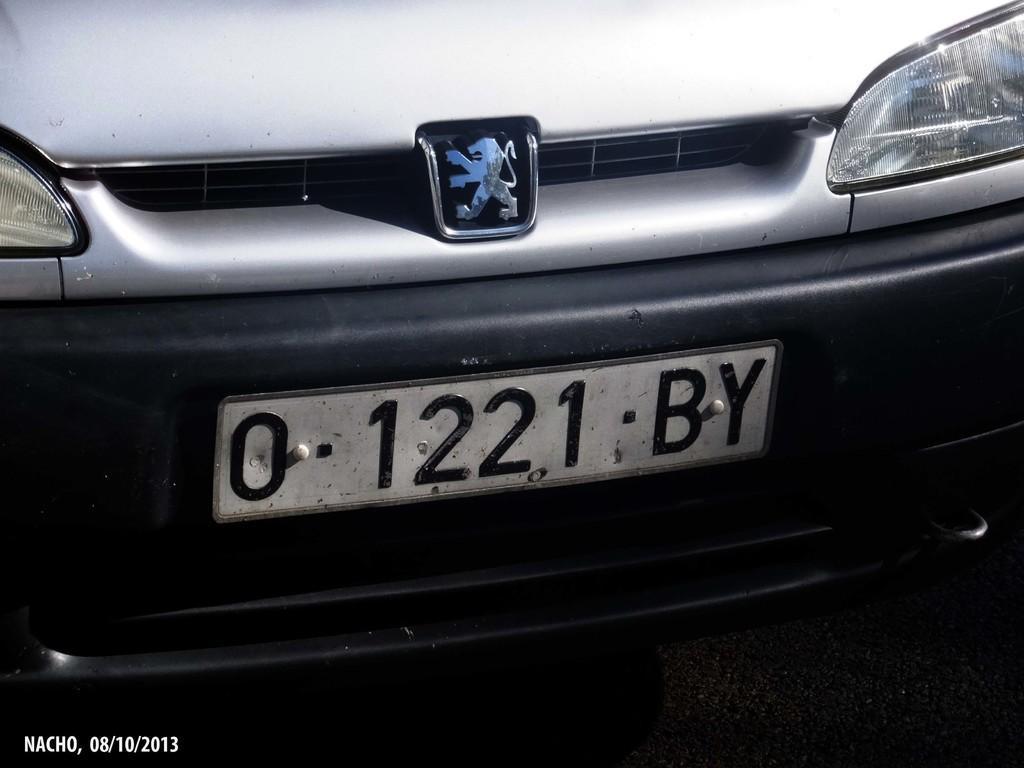Please provide a concise description of this image. In this image, we can see a front view of a vehicle and there is a number plate and there are lights. At the bottom, there is some text. 